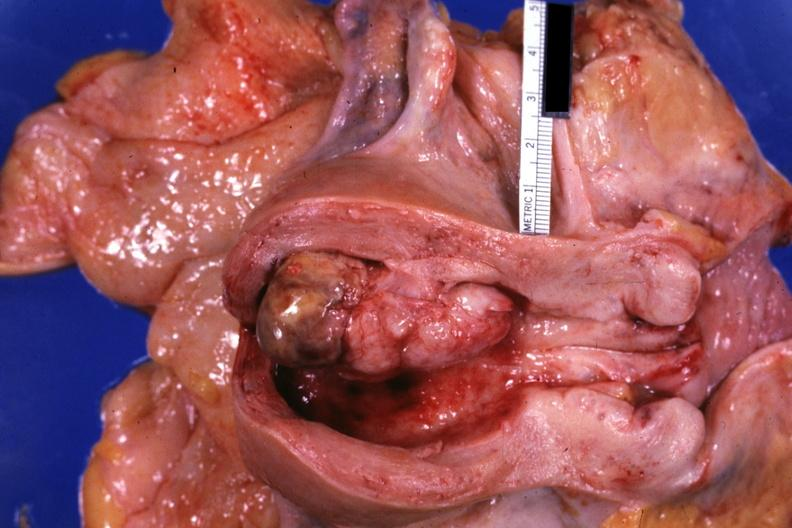what is this opened?
Answer the question using a single word or phrase. Uterus shows tumor 